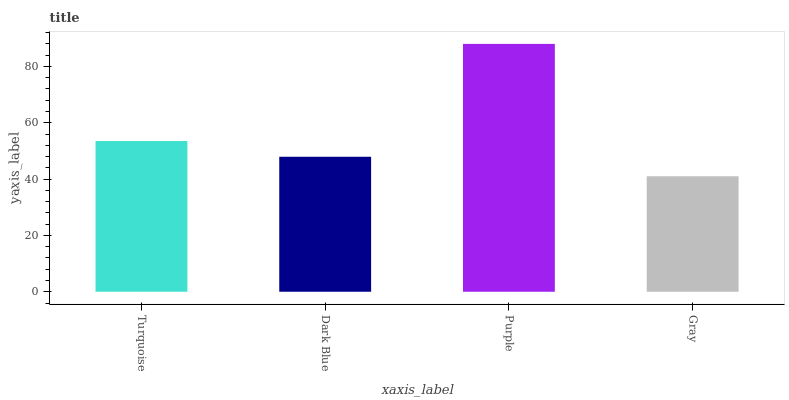Is Gray the minimum?
Answer yes or no. Yes. Is Purple the maximum?
Answer yes or no. Yes. Is Dark Blue the minimum?
Answer yes or no. No. Is Dark Blue the maximum?
Answer yes or no. No. Is Turquoise greater than Dark Blue?
Answer yes or no. Yes. Is Dark Blue less than Turquoise?
Answer yes or no. Yes. Is Dark Blue greater than Turquoise?
Answer yes or no. No. Is Turquoise less than Dark Blue?
Answer yes or no. No. Is Turquoise the high median?
Answer yes or no. Yes. Is Dark Blue the low median?
Answer yes or no. Yes. Is Dark Blue the high median?
Answer yes or no. No. Is Gray the low median?
Answer yes or no. No. 